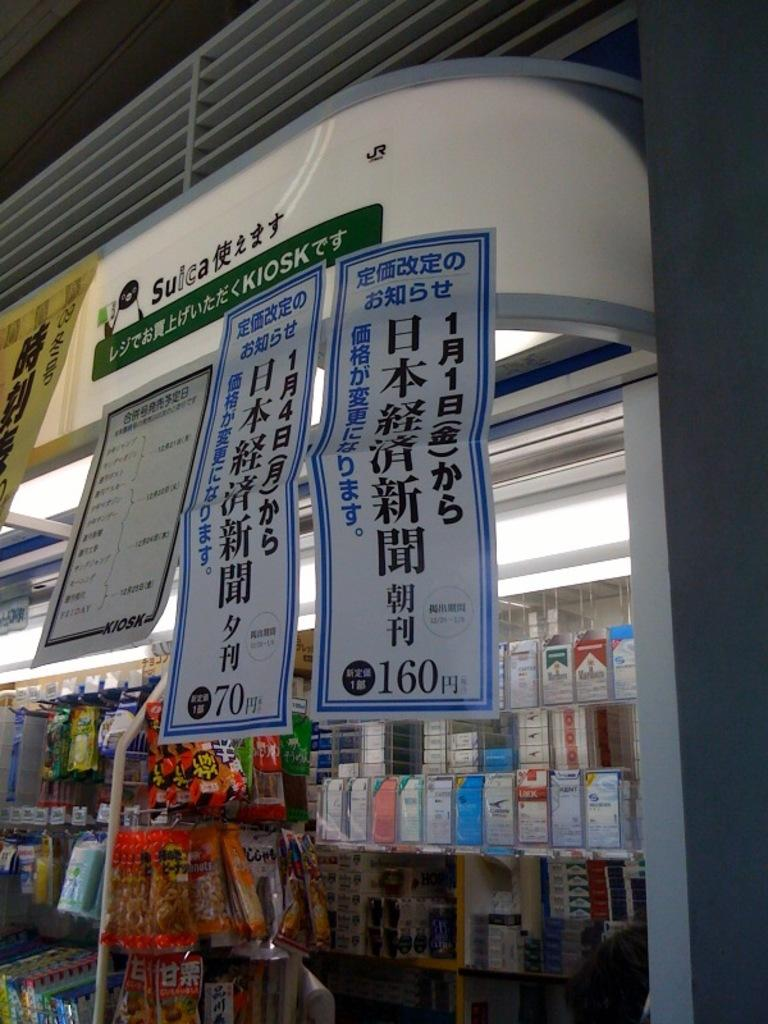<image>
Present a compact description of the photo's key features. A green sign indicates a Kiosk above a store shelf. 